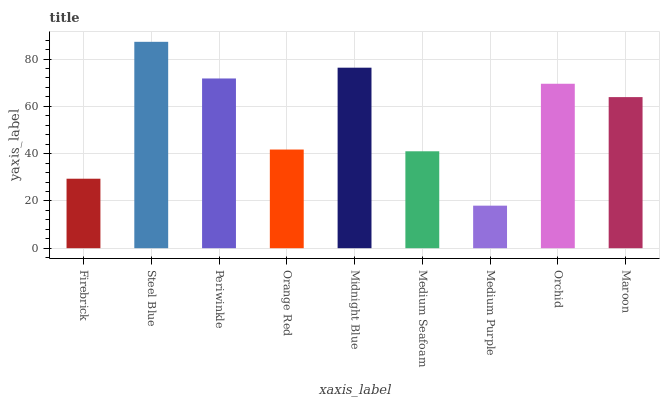Is Medium Purple the minimum?
Answer yes or no. Yes. Is Steel Blue the maximum?
Answer yes or no. Yes. Is Periwinkle the minimum?
Answer yes or no. No. Is Periwinkle the maximum?
Answer yes or no. No. Is Steel Blue greater than Periwinkle?
Answer yes or no. Yes. Is Periwinkle less than Steel Blue?
Answer yes or no. Yes. Is Periwinkle greater than Steel Blue?
Answer yes or no. No. Is Steel Blue less than Periwinkle?
Answer yes or no. No. Is Maroon the high median?
Answer yes or no. Yes. Is Maroon the low median?
Answer yes or no. Yes. Is Medium Purple the high median?
Answer yes or no. No. Is Medium Seafoam the low median?
Answer yes or no. No. 